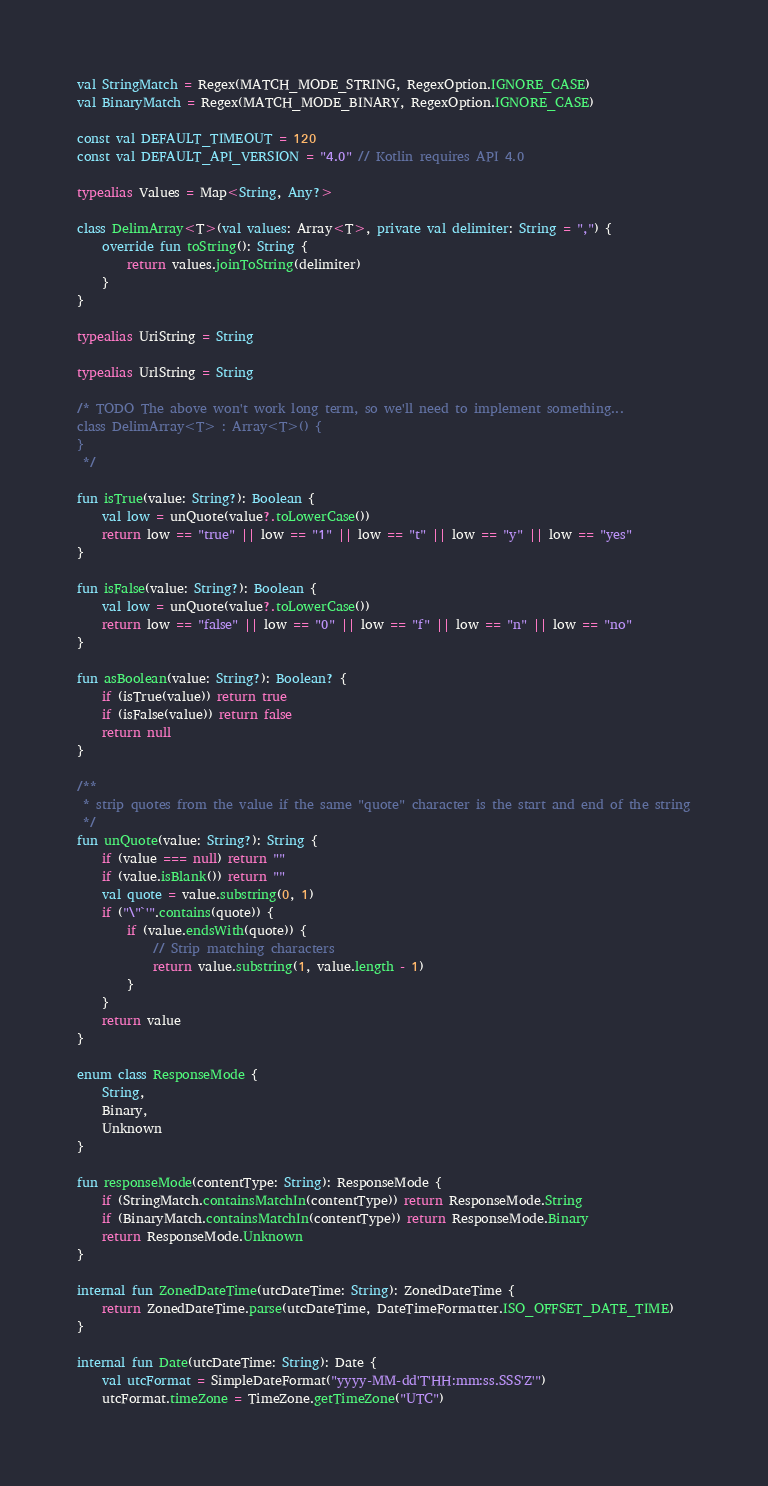<code> <loc_0><loc_0><loc_500><loc_500><_Kotlin_>
val StringMatch = Regex(MATCH_MODE_STRING, RegexOption.IGNORE_CASE)
val BinaryMatch = Regex(MATCH_MODE_BINARY, RegexOption.IGNORE_CASE)

const val DEFAULT_TIMEOUT = 120
const val DEFAULT_API_VERSION = "4.0" // Kotlin requires API 4.0

typealias Values = Map<String, Any?>

class DelimArray<T>(val values: Array<T>, private val delimiter: String = ",") {
    override fun toString(): String {
        return values.joinToString(delimiter)
    }
}

typealias UriString = String

typealias UrlString = String

/* TODO The above won't work long term, so we'll need to implement something...
class DelimArray<T> : Array<T>() {
}
 */

fun isTrue(value: String?): Boolean {
    val low = unQuote(value?.toLowerCase())
    return low == "true" || low == "1" || low == "t" || low == "y" || low == "yes"
}

fun isFalse(value: String?): Boolean {
    val low = unQuote(value?.toLowerCase())
    return low == "false" || low == "0" || low == "f" || low == "n" || low == "no"
}

fun asBoolean(value: String?): Boolean? {
    if (isTrue(value)) return true
    if (isFalse(value)) return false
    return null
}

/**
 * strip quotes from the value if the same "quote" character is the start and end of the string
 */
fun unQuote(value: String?): String {
    if (value === null) return ""
    if (value.isBlank()) return ""
    val quote = value.substring(0, 1)
    if ("\"`'".contains(quote)) {
        if (value.endsWith(quote)) {
            // Strip matching characters
            return value.substring(1, value.length - 1)
        }
    }
    return value
}

enum class ResponseMode {
    String,
    Binary,
    Unknown
}

fun responseMode(contentType: String): ResponseMode {
    if (StringMatch.containsMatchIn(contentType)) return ResponseMode.String
    if (BinaryMatch.containsMatchIn(contentType)) return ResponseMode.Binary
    return ResponseMode.Unknown
}

internal fun ZonedDateTime(utcDateTime: String): ZonedDateTime {
    return ZonedDateTime.parse(utcDateTime, DateTimeFormatter.ISO_OFFSET_DATE_TIME)
}

internal fun Date(utcDateTime: String): Date {
    val utcFormat = SimpleDateFormat("yyyy-MM-dd'T'HH:mm:ss.SSS'Z'")
    utcFormat.timeZone = TimeZone.getTimeZone("UTC")</code> 